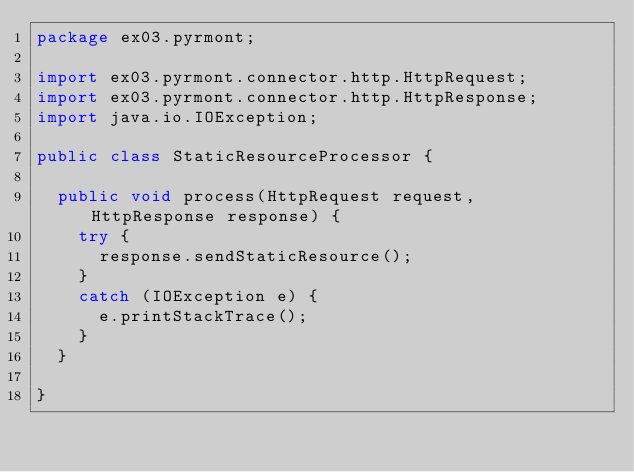Convert code to text. <code><loc_0><loc_0><loc_500><loc_500><_Java_>package ex03.pyrmont;

import ex03.pyrmont.connector.http.HttpRequest;
import ex03.pyrmont.connector.http.HttpResponse;
import java.io.IOException;

public class StaticResourceProcessor {

  public void process(HttpRequest request, HttpResponse response) {
    try {
      response.sendStaticResource();
    }
    catch (IOException e) {
      e.printStackTrace();
    }
  }

}
</code> 